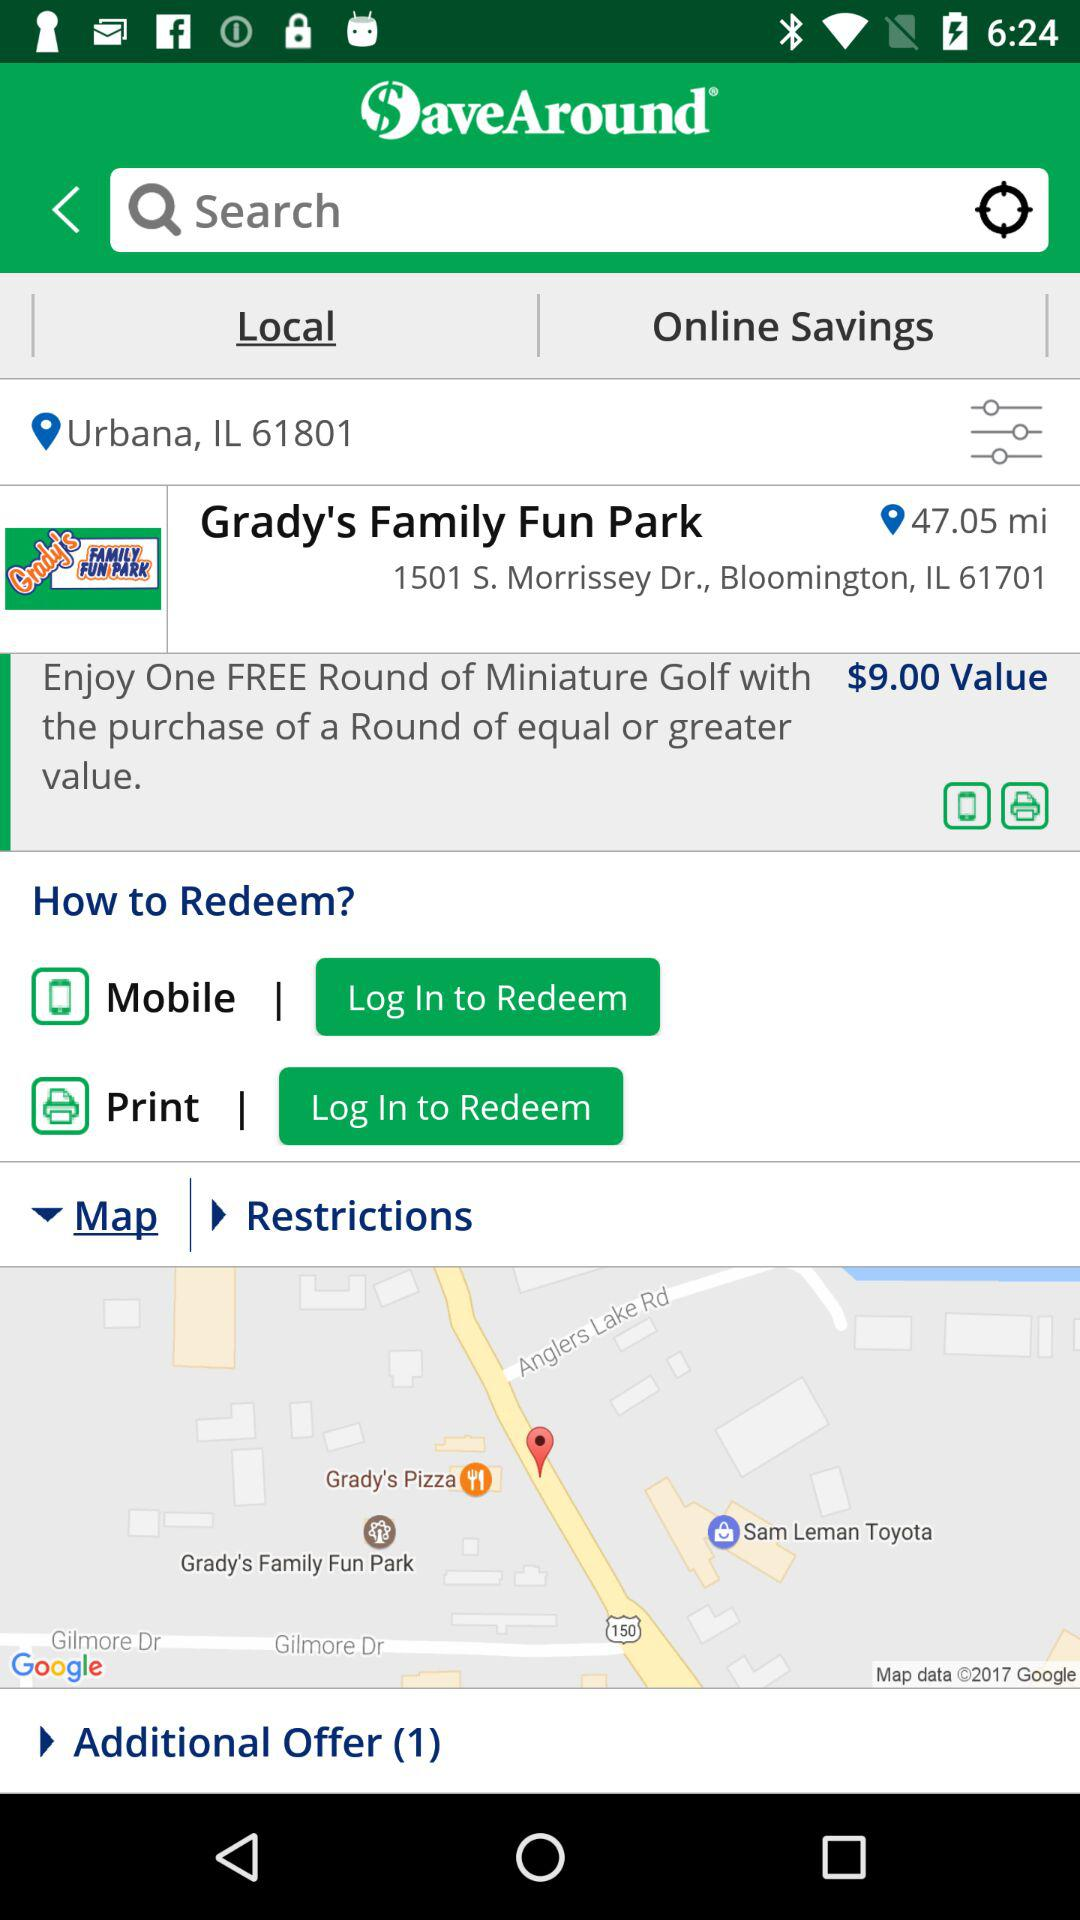What is the address of the park? The address is 1501 S. Morrissey Dr., Bloomington, IL 61701. 